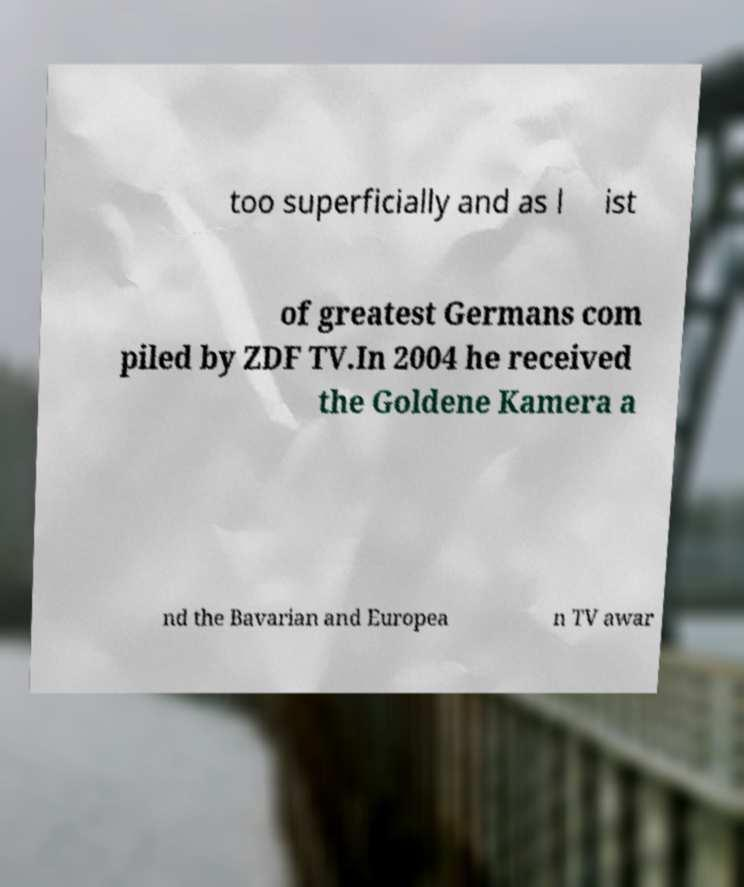Could you assist in decoding the text presented in this image and type it out clearly? too superficially and as l ist of greatest Germans com piled by ZDF TV.In 2004 he received the Goldene Kamera a nd the Bavarian and Europea n TV awar 